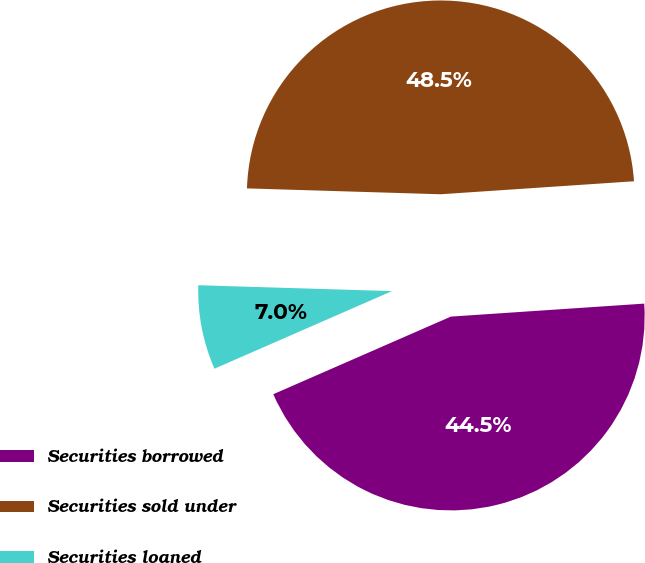Convert chart. <chart><loc_0><loc_0><loc_500><loc_500><pie_chart><fcel>Securities borrowed<fcel>Securities sold under<fcel>Securities loaned<nl><fcel>44.51%<fcel>48.45%<fcel>7.04%<nl></chart> 